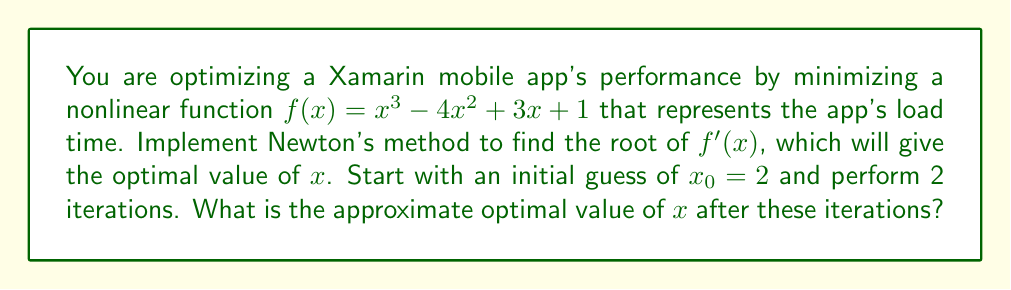Could you help me with this problem? 1. Newton's method formula: $x_{n+1} = x_n - \frac{f(x_n)}{f'(x_n)}$

2. For our problem, we need to find the root of $f'(x)$, so we'll use:
   $f'(x) = 3x^2 - 8x + 3$
   $f''(x) = 6x - 8$

3. Iteration 1:
   $x_0 = 2$
   $x_1 = x_0 - \frac{f'(x_0)}{f''(x_0)}$
   $x_1 = 2 - \frac{3(2)^2 - 8(2) + 3}{6(2) - 8}$
   $x_1 = 2 - \frac{12 - 16 + 3}{12 - 8}$
   $x_1 = 2 - \frac{-1}{4} = 2.25$

4. Iteration 2:
   $x_1 = 2.25$
   $x_2 = x_1 - \frac{f'(x_1)}{f''(x_1)}$
   $x_2 = 2.25 - \frac{3(2.25)^2 - 8(2.25) + 3}{6(2.25) - 8}$
   $x_2 = 2.25 - \frac{15.1875 - 18 + 3}{13.5 - 8}$
   $x_2 = 2.25 - \frac{0.1875}{5.5} \approx 2.2159$
Answer: $x \approx 2.2159$ 